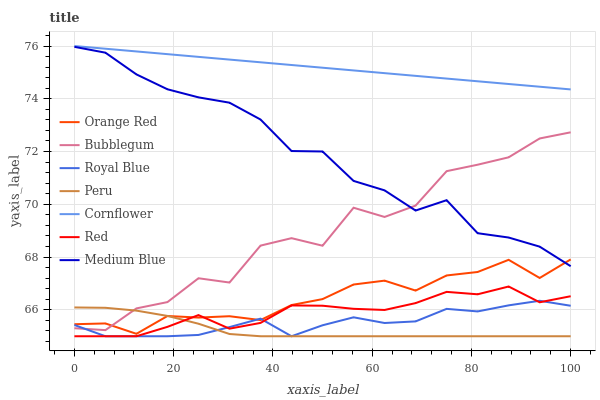Does Peru have the minimum area under the curve?
Answer yes or no. Yes. Does Cornflower have the maximum area under the curve?
Answer yes or no. Yes. Does Medium Blue have the minimum area under the curve?
Answer yes or no. No. Does Medium Blue have the maximum area under the curve?
Answer yes or no. No. Is Cornflower the smoothest?
Answer yes or no. Yes. Is Bubblegum the roughest?
Answer yes or no. Yes. Is Medium Blue the smoothest?
Answer yes or no. No. Is Medium Blue the roughest?
Answer yes or no. No. Does Royal Blue have the lowest value?
Answer yes or no. Yes. Does Medium Blue have the lowest value?
Answer yes or no. No. Does Cornflower have the highest value?
Answer yes or no. Yes. Does Medium Blue have the highest value?
Answer yes or no. No. Is Peru less than Cornflower?
Answer yes or no. Yes. Is Medium Blue greater than Peru?
Answer yes or no. Yes. Does Bubblegum intersect Orange Red?
Answer yes or no. Yes. Is Bubblegum less than Orange Red?
Answer yes or no. No. Is Bubblegum greater than Orange Red?
Answer yes or no. No. Does Peru intersect Cornflower?
Answer yes or no. No. 